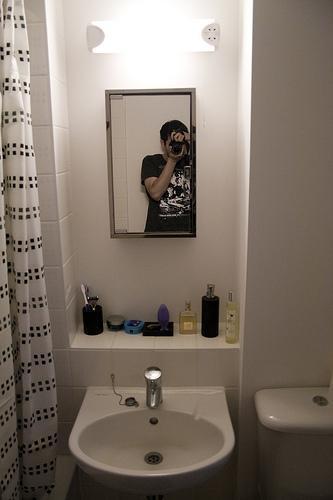How many people are visible?
Give a very brief answer. 1. 